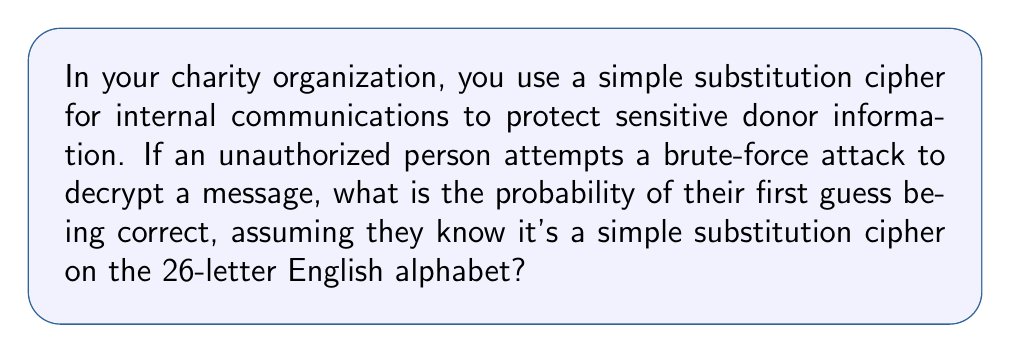Show me your answer to this math problem. Let's approach this step-by-step:

1) A simple substitution cipher replaces each letter in the plaintext with a different letter in the alphabet.

2) For the first letter, the attacker has 26 choices.

3) For the second letter, they have 25 choices (as one letter has already been used).

4) This continues until all 26 letters have been assigned.

5) The total number of possible arrangements is therefore:

   $$26! = 26 \times 25 \times 24 \times ... \times 2 \times 1$$

6) This can be written as:

   $$26! = 403,291,461,126,605,635,584,000,000$$

7) The probability of guessing correctly on the first try is:

   $$P(\text{correct guess}) = \frac{1}{\text{total number of possibilities}}$$

8) Substituting the value we calculated:

   $$P(\text{correct guess}) = \frac{1}{26!} = \frac{1}{403,291,461,126,605,635,584,000,000}$$

9) This is approximately $2.48 \times 10^{-27}$
Answer: $\frac{1}{26!}$ or approximately $2.48 \times 10^{-27}$ 